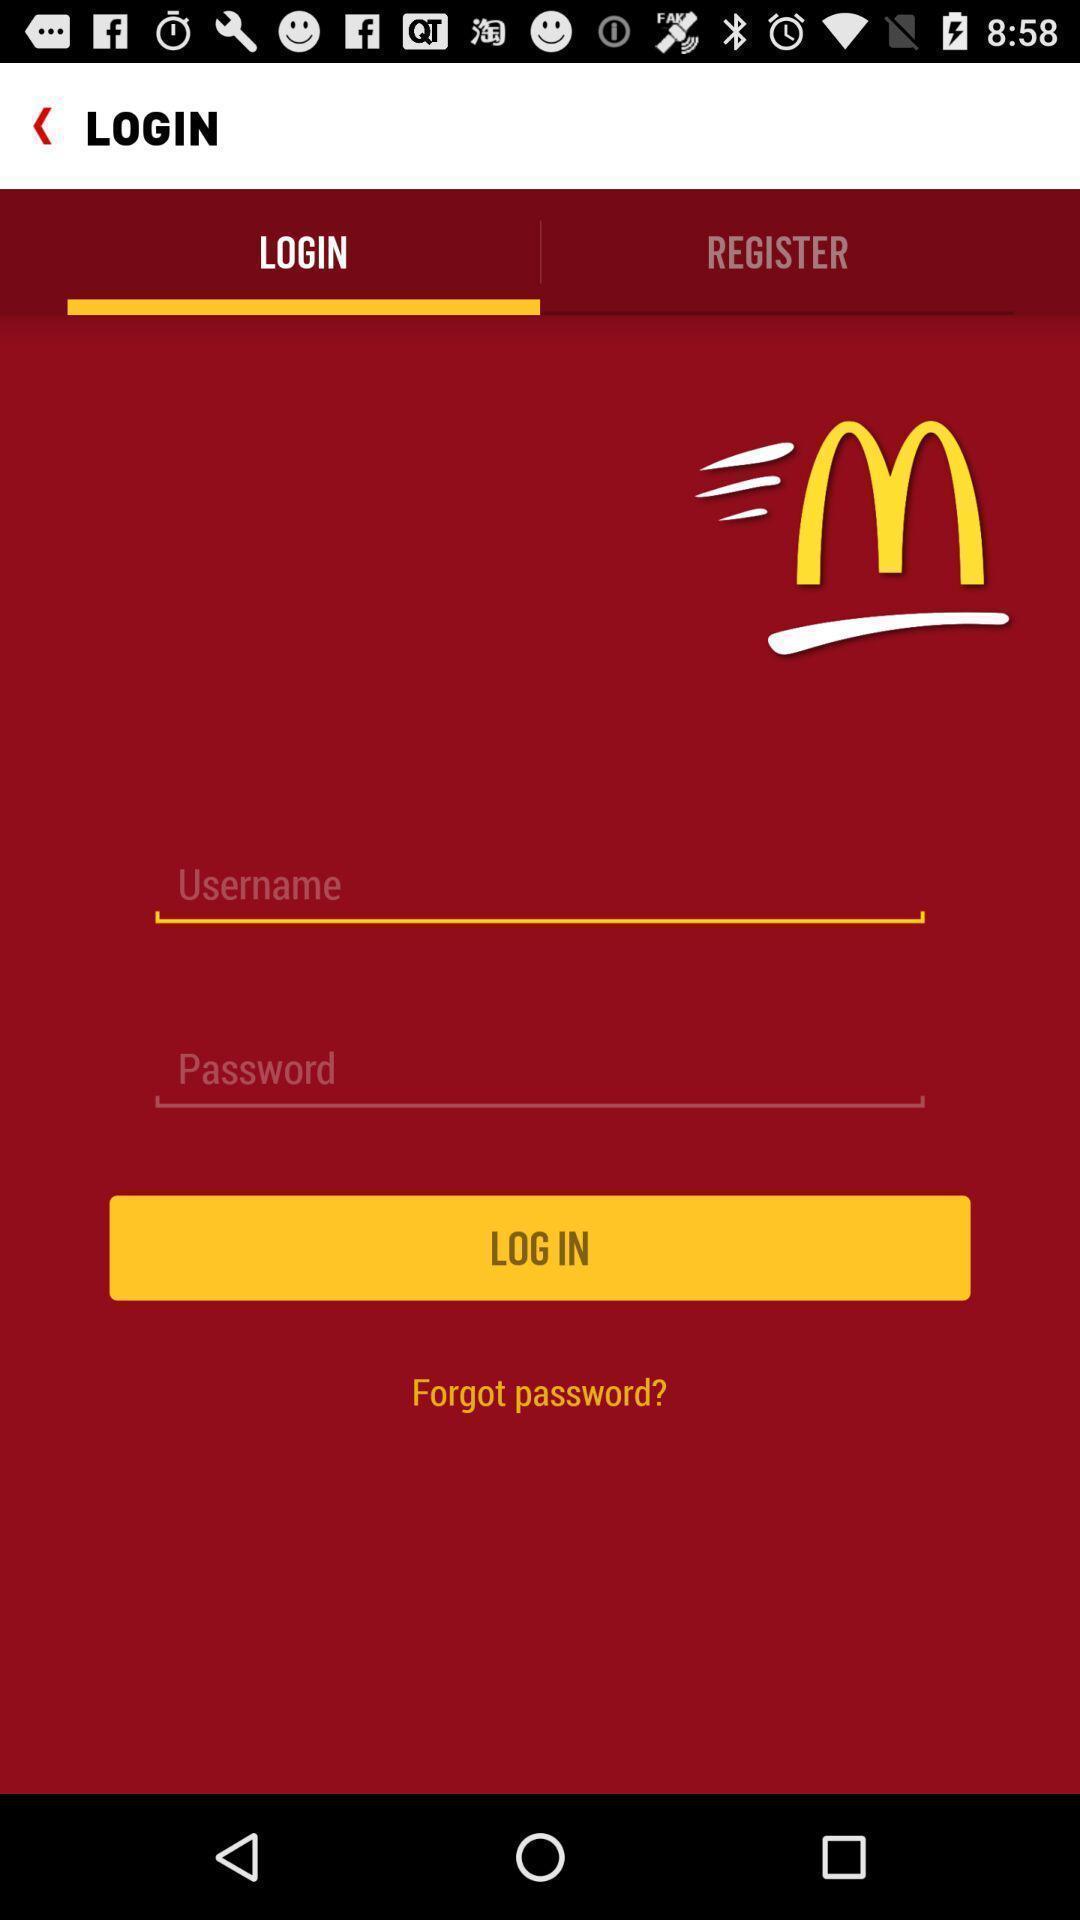Give me a narrative description of this picture. Screen displaying the login page. 